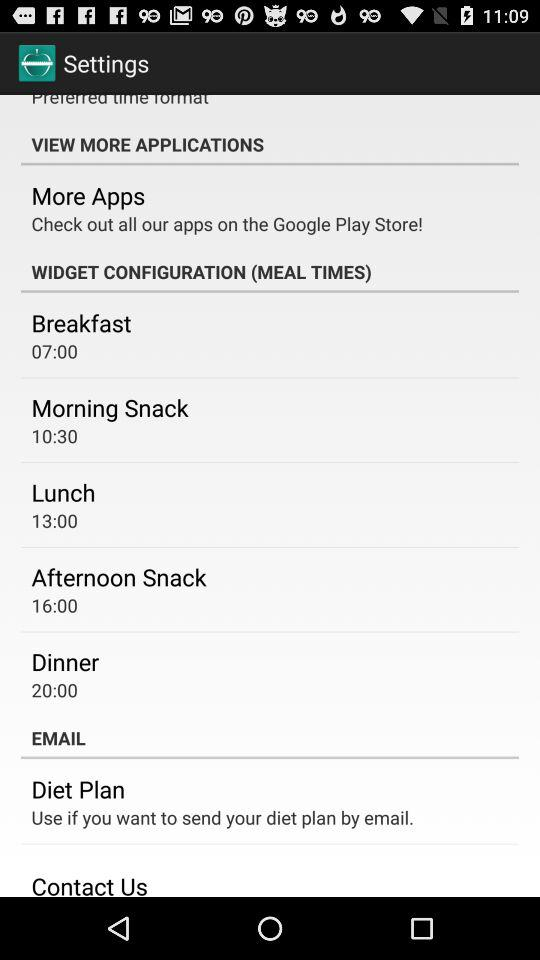What is the afternoon snack time? The afternoon snack time is 16:00. 